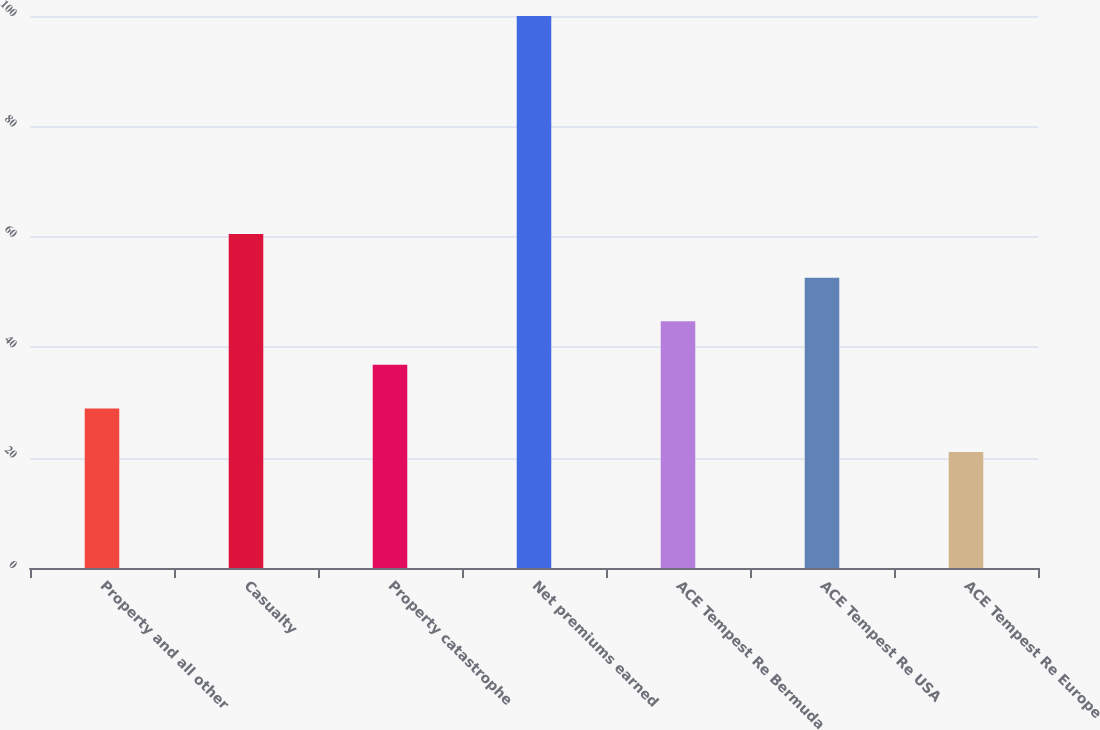<chart> <loc_0><loc_0><loc_500><loc_500><bar_chart><fcel>Property and all other<fcel>Casualty<fcel>Property catastrophe<fcel>Net premiums earned<fcel>ACE Tempest Re Bermuda<fcel>ACE Tempest Re USA<fcel>ACE Tempest Re Europe<nl><fcel>28.9<fcel>60.5<fcel>36.8<fcel>100<fcel>44.7<fcel>52.6<fcel>21<nl></chart> 